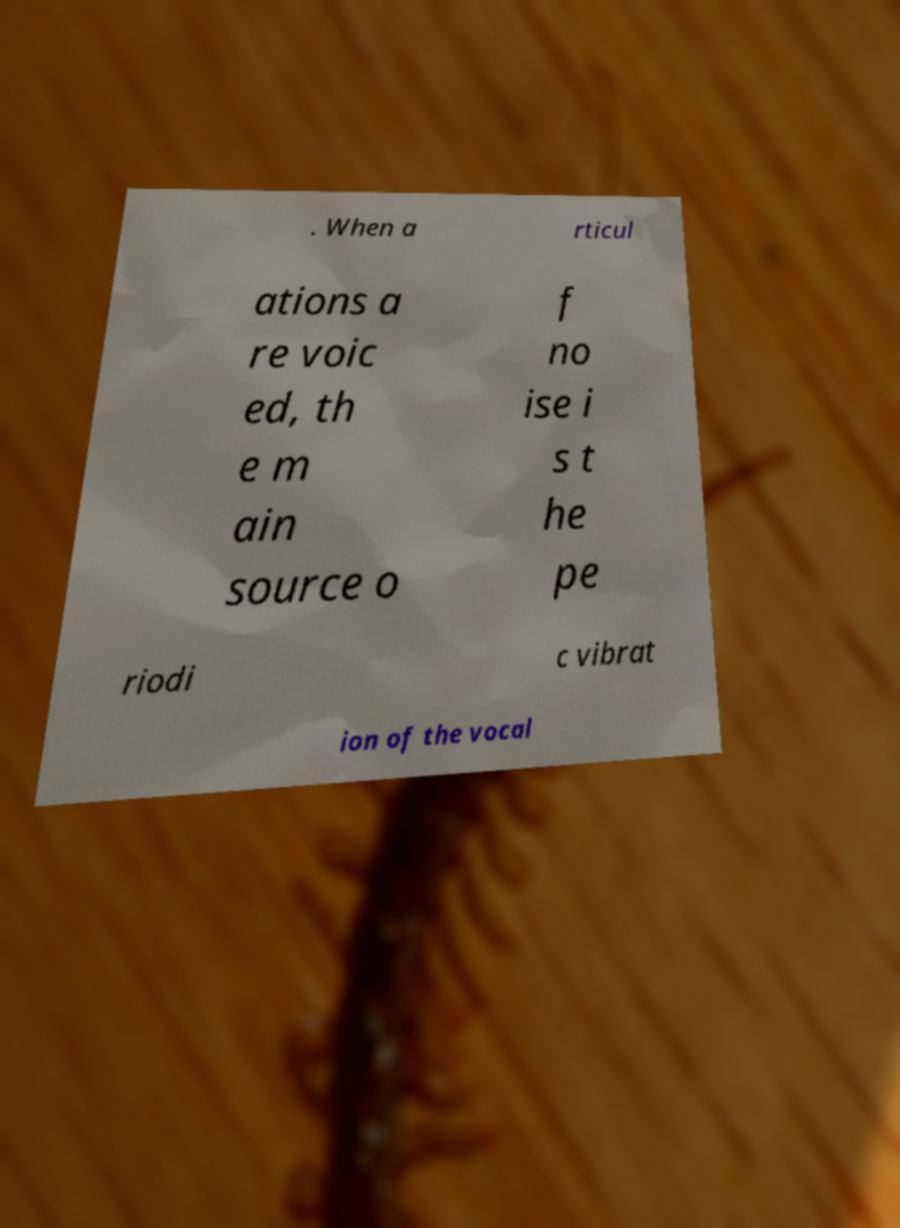What messages or text are displayed in this image? I need them in a readable, typed format. . When a rticul ations a re voic ed, th e m ain source o f no ise i s t he pe riodi c vibrat ion of the vocal 